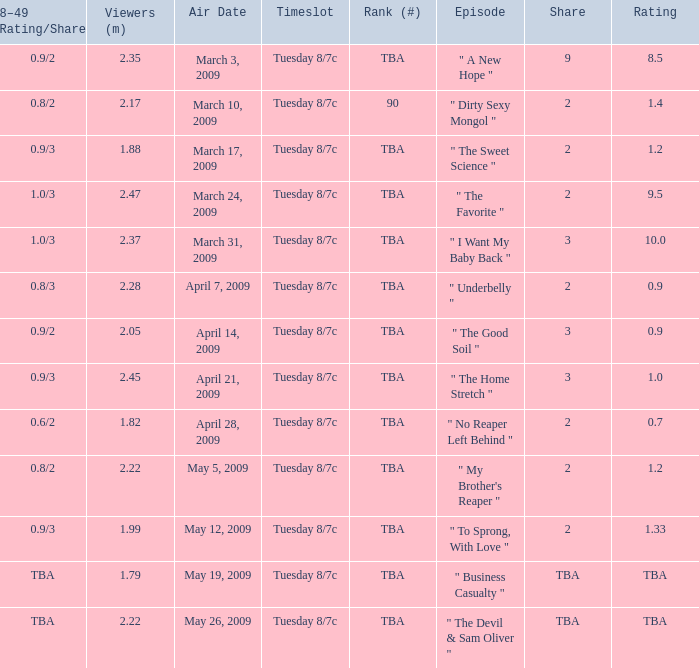What is the rating of the show ranked tba, aired on April 21, 2009? 1.0. Give me the full table as a dictionary. {'header': ['18–49 (Rating/Share)', 'Viewers (m)', 'Air Date', 'Timeslot', 'Rank (#)', 'Episode', 'Share', 'Rating'], 'rows': [['0.9/2', '2.35', 'March 3, 2009', 'Tuesday 8/7c', 'TBA', '" A New Hope "', '9', '8.5'], ['0.8/2', '2.17', 'March 10, 2009', 'Tuesday 8/7c', '90', '" Dirty Sexy Mongol "', '2', '1.4'], ['0.9/3', '1.88', 'March 17, 2009', 'Tuesday 8/7c', 'TBA', '" The Sweet Science "', '2', '1.2'], ['1.0/3', '2.47', 'March 24, 2009', 'Tuesday 8/7c', 'TBA', '" The Favorite "', '2', '9.5'], ['1.0/3', '2.37', 'March 31, 2009', 'Tuesday 8/7c', 'TBA', '" I Want My Baby Back "', '3', '10.0'], ['0.8/3', '2.28', 'April 7, 2009', 'Tuesday 8/7c', 'TBA', '" Underbelly "', '2', '0.9'], ['0.9/2', '2.05', 'April 14, 2009', 'Tuesday 8/7c', 'TBA', '" The Good Soil "', '3', '0.9'], ['0.9/3', '2.45', 'April 21, 2009', 'Tuesday 8/7c', 'TBA', '" The Home Stretch "', '3', '1.0'], ['0.6/2', '1.82', 'April 28, 2009', 'Tuesday 8/7c', 'TBA', '" No Reaper Left Behind "', '2', '0.7'], ['0.8/2', '2.22', 'May 5, 2009', 'Tuesday 8/7c', 'TBA', '" My Brother\'s Reaper "', '2', '1.2'], ['0.9/3', '1.99', 'May 12, 2009', 'Tuesday 8/7c', 'TBA', '" To Sprong, With Love "', '2', '1.33'], ['TBA', '1.79', 'May 19, 2009', 'Tuesday 8/7c', 'TBA', '" Business Casualty "', 'TBA', 'TBA'], ['TBA', '2.22', 'May 26, 2009', 'Tuesday 8/7c', 'TBA', '" The Devil & Sam Oliver "', 'TBA', 'TBA']]} 